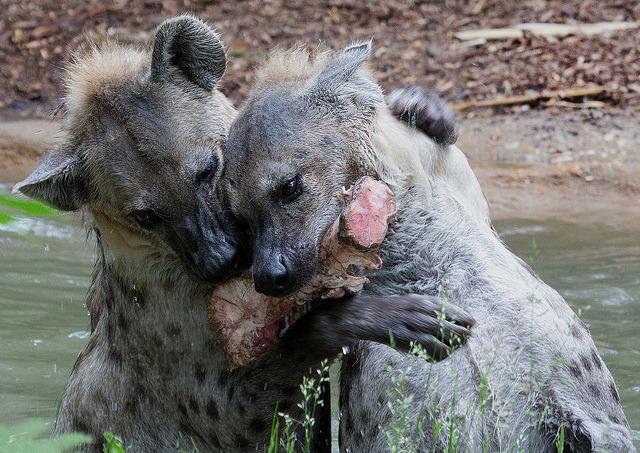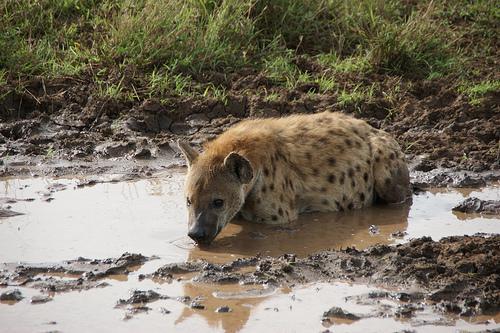The first image is the image on the left, the second image is the image on the right. Assess this claim about the two images: "Exactly one of the images shows hyenas in a wet area.". Correct or not? Answer yes or no. No. The first image is the image on the left, the second image is the image on the right. Assess this claim about the two images: "The left image contains one adult hyena and one baby hyena.". Correct or not? Answer yes or no. No. 